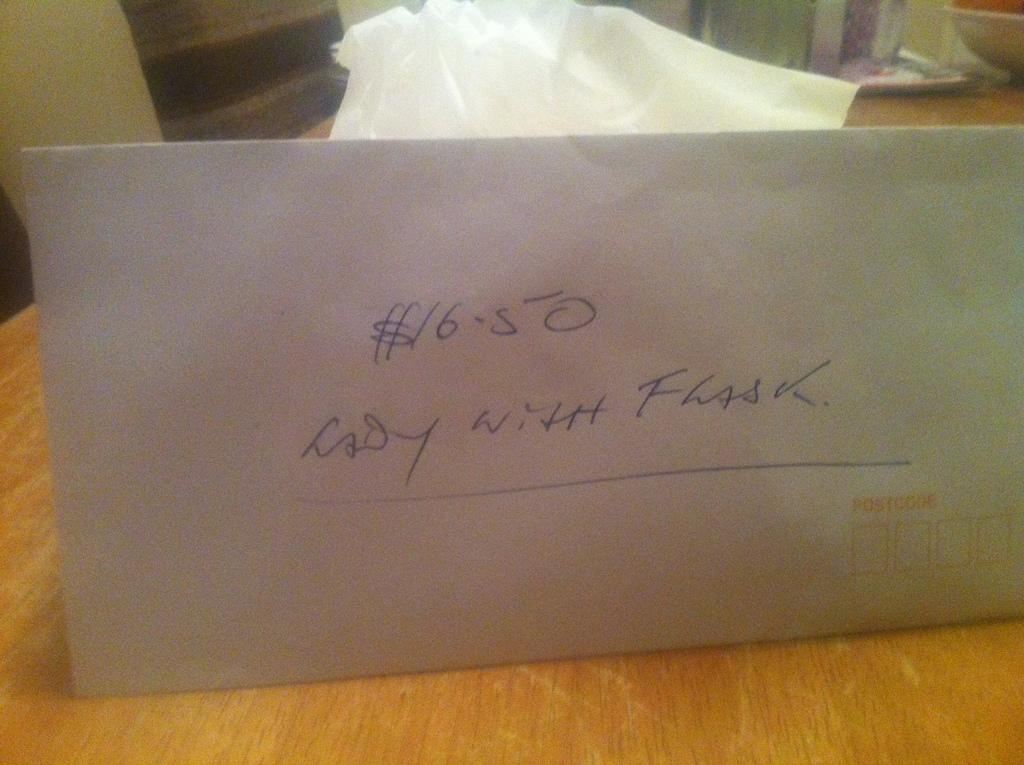<image>
Summarize the visual content of the image. an envelope with the words $16.50 Lady with Flask 